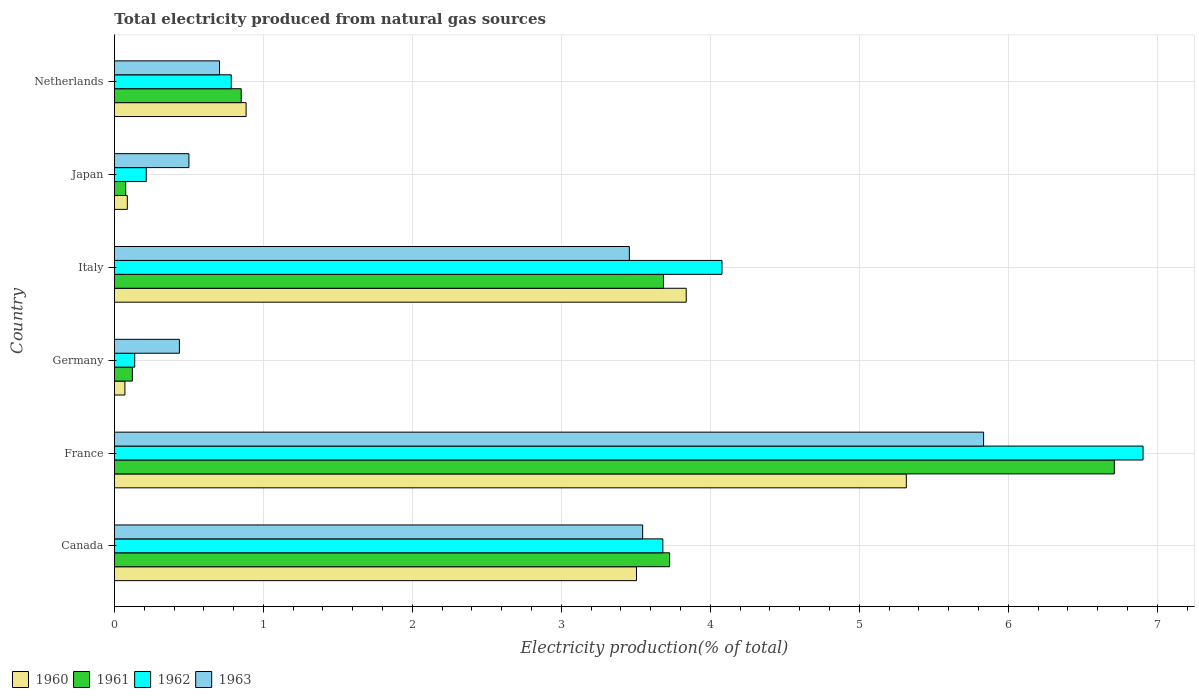How many different coloured bars are there?
Give a very brief answer. 4. Are the number of bars on each tick of the Y-axis equal?
Provide a succinct answer. Yes. What is the label of the 6th group of bars from the top?
Keep it short and to the point. Canada. In how many cases, is the number of bars for a given country not equal to the number of legend labels?
Offer a terse response. 0. What is the total electricity produced in 1963 in Germany?
Provide a succinct answer. 0.44. Across all countries, what is the maximum total electricity produced in 1960?
Ensure brevity in your answer.  5.32. Across all countries, what is the minimum total electricity produced in 1962?
Provide a short and direct response. 0.14. In which country was the total electricity produced in 1963 maximum?
Keep it short and to the point. France. What is the total total electricity produced in 1961 in the graph?
Offer a very short reply. 15.17. What is the difference between the total electricity produced in 1960 in Japan and that in Netherlands?
Offer a very short reply. -0.8. What is the difference between the total electricity produced in 1960 in France and the total electricity produced in 1961 in Netherlands?
Give a very brief answer. 4.46. What is the average total electricity produced in 1963 per country?
Offer a very short reply. 2.41. What is the difference between the total electricity produced in 1961 and total electricity produced in 1963 in Netherlands?
Your answer should be compact. 0.15. What is the ratio of the total electricity produced in 1960 in Canada to that in Italy?
Provide a short and direct response. 0.91. What is the difference between the highest and the second highest total electricity produced in 1961?
Provide a short and direct response. 2.99. What is the difference between the highest and the lowest total electricity produced in 1960?
Provide a succinct answer. 5.25. Is the sum of the total electricity produced in 1962 in France and Germany greater than the maximum total electricity produced in 1963 across all countries?
Ensure brevity in your answer.  Yes. Is it the case that in every country, the sum of the total electricity produced in 1962 and total electricity produced in 1960 is greater than the sum of total electricity produced in 1963 and total electricity produced in 1961?
Ensure brevity in your answer.  No. What does the 4th bar from the bottom in Canada represents?
Offer a terse response. 1963. Is it the case that in every country, the sum of the total electricity produced in 1962 and total electricity produced in 1961 is greater than the total electricity produced in 1960?
Provide a short and direct response. Yes. How many bars are there?
Keep it short and to the point. 24. Are all the bars in the graph horizontal?
Your answer should be very brief. Yes. How many countries are there in the graph?
Make the answer very short. 6. Does the graph contain any zero values?
Your answer should be very brief. No. Where does the legend appear in the graph?
Provide a succinct answer. Bottom left. What is the title of the graph?
Ensure brevity in your answer.  Total electricity produced from natural gas sources. What is the Electricity production(% of total) in 1960 in Canada?
Provide a short and direct response. 3.5. What is the Electricity production(% of total) of 1961 in Canada?
Your answer should be compact. 3.73. What is the Electricity production(% of total) in 1962 in Canada?
Provide a succinct answer. 3.68. What is the Electricity production(% of total) of 1963 in Canada?
Make the answer very short. 3.55. What is the Electricity production(% of total) of 1960 in France?
Provide a succinct answer. 5.32. What is the Electricity production(% of total) in 1961 in France?
Provide a short and direct response. 6.71. What is the Electricity production(% of total) of 1962 in France?
Your answer should be very brief. 6.91. What is the Electricity production(% of total) of 1963 in France?
Keep it short and to the point. 5.83. What is the Electricity production(% of total) in 1960 in Germany?
Give a very brief answer. 0.07. What is the Electricity production(% of total) of 1961 in Germany?
Your response must be concise. 0.12. What is the Electricity production(% of total) in 1962 in Germany?
Make the answer very short. 0.14. What is the Electricity production(% of total) of 1963 in Germany?
Ensure brevity in your answer.  0.44. What is the Electricity production(% of total) of 1960 in Italy?
Offer a very short reply. 3.84. What is the Electricity production(% of total) of 1961 in Italy?
Your answer should be compact. 3.69. What is the Electricity production(% of total) of 1962 in Italy?
Provide a short and direct response. 4.08. What is the Electricity production(% of total) in 1963 in Italy?
Offer a terse response. 3.46. What is the Electricity production(% of total) in 1960 in Japan?
Your answer should be compact. 0.09. What is the Electricity production(% of total) in 1961 in Japan?
Ensure brevity in your answer.  0.08. What is the Electricity production(% of total) in 1962 in Japan?
Offer a very short reply. 0.21. What is the Electricity production(% of total) in 1963 in Japan?
Offer a terse response. 0.5. What is the Electricity production(% of total) in 1960 in Netherlands?
Your answer should be very brief. 0.88. What is the Electricity production(% of total) of 1961 in Netherlands?
Keep it short and to the point. 0.85. What is the Electricity production(% of total) of 1962 in Netherlands?
Offer a very short reply. 0.78. What is the Electricity production(% of total) in 1963 in Netherlands?
Provide a succinct answer. 0.71. Across all countries, what is the maximum Electricity production(% of total) of 1960?
Your answer should be very brief. 5.32. Across all countries, what is the maximum Electricity production(% of total) of 1961?
Provide a succinct answer. 6.71. Across all countries, what is the maximum Electricity production(% of total) in 1962?
Keep it short and to the point. 6.91. Across all countries, what is the maximum Electricity production(% of total) in 1963?
Your response must be concise. 5.83. Across all countries, what is the minimum Electricity production(% of total) of 1960?
Offer a terse response. 0.07. Across all countries, what is the minimum Electricity production(% of total) in 1961?
Make the answer very short. 0.08. Across all countries, what is the minimum Electricity production(% of total) of 1962?
Provide a short and direct response. 0.14. Across all countries, what is the minimum Electricity production(% of total) of 1963?
Your response must be concise. 0.44. What is the total Electricity production(% of total) in 1960 in the graph?
Provide a succinct answer. 13.7. What is the total Electricity production(% of total) of 1961 in the graph?
Offer a terse response. 15.17. What is the total Electricity production(% of total) of 1962 in the graph?
Ensure brevity in your answer.  15.8. What is the total Electricity production(% of total) in 1963 in the graph?
Give a very brief answer. 14.48. What is the difference between the Electricity production(% of total) in 1960 in Canada and that in France?
Ensure brevity in your answer.  -1.81. What is the difference between the Electricity production(% of total) of 1961 in Canada and that in France?
Offer a very short reply. -2.99. What is the difference between the Electricity production(% of total) in 1962 in Canada and that in France?
Ensure brevity in your answer.  -3.22. What is the difference between the Electricity production(% of total) of 1963 in Canada and that in France?
Offer a terse response. -2.29. What is the difference between the Electricity production(% of total) in 1960 in Canada and that in Germany?
Your response must be concise. 3.43. What is the difference between the Electricity production(% of total) of 1961 in Canada and that in Germany?
Ensure brevity in your answer.  3.61. What is the difference between the Electricity production(% of total) in 1962 in Canada and that in Germany?
Ensure brevity in your answer.  3.55. What is the difference between the Electricity production(% of total) in 1963 in Canada and that in Germany?
Your answer should be very brief. 3.11. What is the difference between the Electricity production(% of total) of 1960 in Canada and that in Italy?
Make the answer very short. -0.33. What is the difference between the Electricity production(% of total) of 1961 in Canada and that in Italy?
Ensure brevity in your answer.  0.04. What is the difference between the Electricity production(% of total) of 1962 in Canada and that in Italy?
Offer a terse response. -0.4. What is the difference between the Electricity production(% of total) of 1963 in Canada and that in Italy?
Provide a short and direct response. 0.09. What is the difference between the Electricity production(% of total) of 1960 in Canada and that in Japan?
Offer a terse response. 3.42. What is the difference between the Electricity production(% of total) of 1961 in Canada and that in Japan?
Your response must be concise. 3.65. What is the difference between the Electricity production(% of total) in 1962 in Canada and that in Japan?
Make the answer very short. 3.47. What is the difference between the Electricity production(% of total) in 1963 in Canada and that in Japan?
Provide a short and direct response. 3.05. What is the difference between the Electricity production(% of total) in 1960 in Canada and that in Netherlands?
Offer a very short reply. 2.62. What is the difference between the Electricity production(% of total) in 1961 in Canada and that in Netherlands?
Make the answer very short. 2.88. What is the difference between the Electricity production(% of total) of 1962 in Canada and that in Netherlands?
Provide a short and direct response. 2.9. What is the difference between the Electricity production(% of total) of 1963 in Canada and that in Netherlands?
Make the answer very short. 2.84. What is the difference between the Electricity production(% of total) of 1960 in France and that in Germany?
Offer a terse response. 5.25. What is the difference between the Electricity production(% of total) in 1961 in France and that in Germany?
Keep it short and to the point. 6.59. What is the difference between the Electricity production(% of total) of 1962 in France and that in Germany?
Provide a succinct answer. 6.77. What is the difference between the Electricity production(% of total) of 1963 in France and that in Germany?
Provide a succinct answer. 5.4. What is the difference between the Electricity production(% of total) in 1960 in France and that in Italy?
Make the answer very short. 1.48. What is the difference between the Electricity production(% of total) of 1961 in France and that in Italy?
Offer a very short reply. 3.03. What is the difference between the Electricity production(% of total) of 1962 in France and that in Italy?
Ensure brevity in your answer.  2.83. What is the difference between the Electricity production(% of total) of 1963 in France and that in Italy?
Give a very brief answer. 2.38. What is the difference between the Electricity production(% of total) of 1960 in France and that in Japan?
Make the answer very short. 5.23. What is the difference between the Electricity production(% of total) in 1961 in France and that in Japan?
Provide a succinct answer. 6.64. What is the difference between the Electricity production(% of total) of 1962 in France and that in Japan?
Ensure brevity in your answer.  6.69. What is the difference between the Electricity production(% of total) of 1963 in France and that in Japan?
Make the answer very short. 5.33. What is the difference between the Electricity production(% of total) in 1960 in France and that in Netherlands?
Provide a succinct answer. 4.43. What is the difference between the Electricity production(% of total) of 1961 in France and that in Netherlands?
Ensure brevity in your answer.  5.86. What is the difference between the Electricity production(% of total) of 1962 in France and that in Netherlands?
Give a very brief answer. 6.12. What is the difference between the Electricity production(% of total) of 1963 in France and that in Netherlands?
Make the answer very short. 5.13. What is the difference between the Electricity production(% of total) of 1960 in Germany and that in Italy?
Provide a succinct answer. -3.77. What is the difference between the Electricity production(% of total) of 1961 in Germany and that in Italy?
Your answer should be compact. -3.57. What is the difference between the Electricity production(% of total) in 1962 in Germany and that in Italy?
Make the answer very short. -3.94. What is the difference between the Electricity production(% of total) of 1963 in Germany and that in Italy?
Ensure brevity in your answer.  -3.02. What is the difference between the Electricity production(% of total) in 1960 in Germany and that in Japan?
Your answer should be very brief. -0.02. What is the difference between the Electricity production(% of total) of 1961 in Germany and that in Japan?
Provide a succinct answer. 0.04. What is the difference between the Electricity production(% of total) of 1962 in Germany and that in Japan?
Offer a terse response. -0.08. What is the difference between the Electricity production(% of total) in 1963 in Germany and that in Japan?
Your answer should be compact. -0.06. What is the difference between the Electricity production(% of total) of 1960 in Germany and that in Netherlands?
Ensure brevity in your answer.  -0.81. What is the difference between the Electricity production(% of total) in 1961 in Germany and that in Netherlands?
Your answer should be compact. -0.73. What is the difference between the Electricity production(% of total) in 1962 in Germany and that in Netherlands?
Make the answer very short. -0.65. What is the difference between the Electricity production(% of total) of 1963 in Germany and that in Netherlands?
Offer a very short reply. -0.27. What is the difference between the Electricity production(% of total) in 1960 in Italy and that in Japan?
Your response must be concise. 3.75. What is the difference between the Electricity production(% of total) of 1961 in Italy and that in Japan?
Offer a very short reply. 3.61. What is the difference between the Electricity production(% of total) of 1962 in Italy and that in Japan?
Make the answer very short. 3.86. What is the difference between the Electricity production(% of total) in 1963 in Italy and that in Japan?
Offer a very short reply. 2.96. What is the difference between the Electricity production(% of total) in 1960 in Italy and that in Netherlands?
Keep it short and to the point. 2.95. What is the difference between the Electricity production(% of total) in 1961 in Italy and that in Netherlands?
Make the answer very short. 2.83. What is the difference between the Electricity production(% of total) of 1962 in Italy and that in Netherlands?
Offer a terse response. 3.29. What is the difference between the Electricity production(% of total) of 1963 in Italy and that in Netherlands?
Your response must be concise. 2.75. What is the difference between the Electricity production(% of total) of 1960 in Japan and that in Netherlands?
Make the answer very short. -0.8. What is the difference between the Electricity production(% of total) in 1961 in Japan and that in Netherlands?
Provide a short and direct response. -0.78. What is the difference between the Electricity production(% of total) of 1962 in Japan and that in Netherlands?
Provide a succinct answer. -0.57. What is the difference between the Electricity production(% of total) in 1963 in Japan and that in Netherlands?
Offer a very short reply. -0.21. What is the difference between the Electricity production(% of total) in 1960 in Canada and the Electricity production(% of total) in 1961 in France?
Your answer should be compact. -3.21. What is the difference between the Electricity production(% of total) of 1960 in Canada and the Electricity production(% of total) of 1962 in France?
Your response must be concise. -3.4. What is the difference between the Electricity production(% of total) of 1960 in Canada and the Electricity production(% of total) of 1963 in France?
Offer a terse response. -2.33. What is the difference between the Electricity production(% of total) of 1961 in Canada and the Electricity production(% of total) of 1962 in France?
Offer a terse response. -3.18. What is the difference between the Electricity production(% of total) of 1961 in Canada and the Electricity production(% of total) of 1963 in France?
Your response must be concise. -2.11. What is the difference between the Electricity production(% of total) of 1962 in Canada and the Electricity production(% of total) of 1963 in France?
Offer a very short reply. -2.15. What is the difference between the Electricity production(% of total) in 1960 in Canada and the Electricity production(% of total) in 1961 in Germany?
Provide a short and direct response. 3.38. What is the difference between the Electricity production(% of total) in 1960 in Canada and the Electricity production(% of total) in 1962 in Germany?
Give a very brief answer. 3.37. What is the difference between the Electricity production(% of total) in 1960 in Canada and the Electricity production(% of total) in 1963 in Germany?
Your answer should be compact. 3.07. What is the difference between the Electricity production(% of total) of 1961 in Canada and the Electricity production(% of total) of 1962 in Germany?
Offer a terse response. 3.59. What is the difference between the Electricity production(% of total) in 1961 in Canada and the Electricity production(% of total) in 1963 in Germany?
Offer a very short reply. 3.29. What is the difference between the Electricity production(% of total) of 1962 in Canada and the Electricity production(% of total) of 1963 in Germany?
Your answer should be compact. 3.25. What is the difference between the Electricity production(% of total) of 1960 in Canada and the Electricity production(% of total) of 1961 in Italy?
Give a very brief answer. -0.18. What is the difference between the Electricity production(% of total) of 1960 in Canada and the Electricity production(% of total) of 1962 in Italy?
Make the answer very short. -0.57. What is the difference between the Electricity production(% of total) of 1960 in Canada and the Electricity production(% of total) of 1963 in Italy?
Your answer should be very brief. 0.05. What is the difference between the Electricity production(% of total) in 1961 in Canada and the Electricity production(% of total) in 1962 in Italy?
Your answer should be very brief. -0.35. What is the difference between the Electricity production(% of total) of 1961 in Canada and the Electricity production(% of total) of 1963 in Italy?
Make the answer very short. 0.27. What is the difference between the Electricity production(% of total) of 1962 in Canada and the Electricity production(% of total) of 1963 in Italy?
Your answer should be very brief. 0.23. What is the difference between the Electricity production(% of total) of 1960 in Canada and the Electricity production(% of total) of 1961 in Japan?
Give a very brief answer. 3.43. What is the difference between the Electricity production(% of total) in 1960 in Canada and the Electricity production(% of total) in 1962 in Japan?
Your response must be concise. 3.29. What is the difference between the Electricity production(% of total) of 1960 in Canada and the Electricity production(% of total) of 1963 in Japan?
Your response must be concise. 3. What is the difference between the Electricity production(% of total) of 1961 in Canada and the Electricity production(% of total) of 1962 in Japan?
Your answer should be very brief. 3.51. What is the difference between the Electricity production(% of total) in 1961 in Canada and the Electricity production(% of total) in 1963 in Japan?
Offer a terse response. 3.23. What is the difference between the Electricity production(% of total) of 1962 in Canada and the Electricity production(% of total) of 1963 in Japan?
Offer a terse response. 3.18. What is the difference between the Electricity production(% of total) of 1960 in Canada and the Electricity production(% of total) of 1961 in Netherlands?
Your answer should be compact. 2.65. What is the difference between the Electricity production(% of total) in 1960 in Canada and the Electricity production(% of total) in 1962 in Netherlands?
Provide a succinct answer. 2.72. What is the difference between the Electricity production(% of total) in 1960 in Canada and the Electricity production(% of total) in 1963 in Netherlands?
Your answer should be very brief. 2.8. What is the difference between the Electricity production(% of total) of 1961 in Canada and the Electricity production(% of total) of 1962 in Netherlands?
Provide a succinct answer. 2.94. What is the difference between the Electricity production(% of total) in 1961 in Canada and the Electricity production(% of total) in 1963 in Netherlands?
Give a very brief answer. 3.02. What is the difference between the Electricity production(% of total) of 1962 in Canada and the Electricity production(% of total) of 1963 in Netherlands?
Your answer should be very brief. 2.98. What is the difference between the Electricity production(% of total) in 1960 in France and the Electricity production(% of total) in 1961 in Germany?
Offer a very short reply. 5.2. What is the difference between the Electricity production(% of total) in 1960 in France and the Electricity production(% of total) in 1962 in Germany?
Ensure brevity in your answer.  5.18. What is the difference between the Electricity production(% of total) of 1960 in France and the Electricity production(% of total) of 1963 in Germany?
Your answer should be very brief. 4.88. What is the difference between the Electricity production(% of total) of 1961 in France and the Electricity production(% of total) of 1962 in Germany?
Provide a short and direct response. 6.58. What is the difference between the Electricity production(% of total) of 1961 in France and the Electricity production(% of total) of 1963 in Germany?
Give a very brief answer. 6.28. What is the difference between the Electricity production(% of total) in 1962 in France and the Electricity production(% of total) in 1963 in Germany?
Ensure brevity in your answer.  6.47. What is the difference between the Electricity production(% of total) of 1960 in France and the Electricity production(% of total) of 1961 in Italy?
Your response must be concise. 1.63. What is the difference between the Electricity production(% of total) of 1960 in France and the Electricity production(% of total) of 1962 in Italy?
Provide a succinct answer. 1.24. What is the difference between the Electricity production(% of total) of 1960 in France and the Electricity production(% of total) of 1963 in Italy?
Give a very brief answer. 1.86. What is the difference between the Electricity production(% of total) of 1961 in France and the Electricity production(% of total) of 1962 in Italy?
Offer a terse response. 2.63. What is the difference between the Electricity production(% of total) of 1961 in France and the Electricity production(% of total) of 1963 in Italy?
Your response must be concise. 3.26. What is the difference between the Electricity production(% of total) in 1962 in France and the Electricity production(% of total) in 1963 in Italy?
Keep it short and to the point. 3.45. What is the difference between the Electricity production(% of total) in 1960 in France and the Electricity production(% of total) in 1961 in Japan?
Your answer should be compact. 5.24. What is the difference between the Electricity production(% of total) in 1960 in France and the Electricity production(% of total) in 1962 in Japan?
Give a very brief answer. 5.1. What is the difference between the Electricity production(% of total) of 1960 in France and the Electricity production(% of total) of 1963 in Japan?
Offer a terse response. 4.82. What is the difference between the Electricity production(% of total) of 1961 in France and the Electricity production(% of total) of 1962 in Japan?
Ensure brevity in your answer.  6.5. What is the difference between the Electricity production(% of total) of 1961 in France and the Electricity production(% of total) of 1963 in Japan?
Your response must be concise. 6.21. What is the difference between the Electricity production(% of total) in 1962 in France and the Electricity production(% of total) in 1963 in Japan?
Offer a terse response. 6.4. What is the difference between the Electricity production(% of total) of 1960 in France and the Electricity production(% of total) of 1961 in Netherlands?
Offer a very short reply. 4.46. What is the difference between the Electricity production(% of total) of 1960 in France and the Electricity production(% of total) of 1962 in Netherlands?
Provide a short and direct response. 4.53. What is the difference between the Electricity production(% of total) in 1960 in France and the Electricity production(% of total) in 1963 in Netherlands?
Offer a very short reply. 4.61. What is the difference between the Electricity production(% of total) in 1961 in France and the Electricity production(% of total) in 1962 in Netherlands?
Make the answer very short. 5.93. What is the difference between the Electricity production(% of total) of 1961 in France and the Electricity production(% of total) of 1963 in Netherlands?
Offer a very short reply. 6.01. What is the difference between the Electricity production(% of total) in 1962 in France and the Electricity production(% of total) in 1963 in Netherlands?
Your answer should be very brief. 6.2. What is the difference between the Electricity production(% of total) of 1960 in Germany and the Electricity production(% of total) of 1961 in Italy?
Offer a very short reply. -3.62. What is the difference between the Electricity production(% of total) of 1960 in Germany and the Electricity production(% of total) of 1962 in Italy?
Give a very brief answer. -4.01. What is the difference between the Electricity production(% of total) of 1960 in Germany and the Electricity production(% of total) of 1963 in Italy?
Your answer should be very brief. -3.39. What is the difference between the Electricity production(% of total) in 1961 in Germany and the Electricity production(% of total) in 1962 in Italy?
Your answer should be compact. -3.96. What is the difference between the Electricity production(% of total) of 1961 in Germany and the Electricity production(% of total) of 1963 in Italy?
Give a very brief answer. -3.34. What is the difference between the Electricity production(% of total) in 1962 in Germany and the Electricity production(% of total) in 1963 in Italy?
Offer a very short reply. -3.32. What is the difference between the Electricity production(% of total) of 1960 in Germany and the Electricity production(% of total) of 1961 in Japan?
Your answer should be compact. -0.01. What is the difference between the Electricity production(% of total) in 1960 in Germany and the Electricity production(% of total) in 1962 in Japan?
Offer a terse response. -0.14. What is the difference between the Electricity production(% of total) in 1960 in Germany and the Electricity production(% of total) in 1963 in Japan?
Give a very brief answer. -0.43. What is the difference between the Electricity production(% of total) of 1961 in Germany and the Electricity production(% of total) of 1962 in Japan?
Ensure brevity in your answer.  -0.09. What is the difference between the Electricity production(% of total) in 1961 in Germany and the Electricity production(% of total) in 1963 in Japan?
Provide a short and direct response. -0.38. What is the difference between the Electricity production(% of total) in 1962 in Germany and the Electricity production(% of total) in 1963 in Japan?
Offer a terse response. -0.36. What is the difference between the Electricity production(% of total) in 1960 in Germany and the Electricity production(% of total) in 1961 in Netherlands?
Your answer should be very brief. -0.78. What is the difference between the Electricity production(% of total) in 1960 in Germany and the Electricity production(% of total) in 1962 in Netherlands?
Ensure brevity in your answer.  -0.71. What is the difference between the Electricity production(% of total) of 1960 in Germany and the Electricity production(% of total) of 1963 in Netherlands?
Provide a short and direct response. -0.64. What is the difference between the Electricity production(% of total) of 1961 in Germany and the Electricity production(% of total) of 1962 in Netherlands?
Offer a very short reply. -0.66. What is the difference between the Electricity production(% of total) in 1961 in Germany and the Electricity production(% of total) in 1963 in Netherlands?
Provide a succinct answer. -0.58. What is the difference between the Electricity production(% of total) of 1962 in Germany and the Electricity production(% of total) of 1963 in Netherlands?
Ensure brevity in your answer.  -0.57. What is the difference between the Electricity production(% of total) in 1960 in Italy and the Electricity production(% of total) in 1961 in Japan?
Your answer should be compact. 3.76. What is the difference between the Electricity production(% of total) of 1960 in Italy and the Electricity production(% of total) of 1962 in Japan?
Keep it short and to the point. 3.62. What is the difference between the Electricity production(% of total) of 1960 in Italy and the Electricity production(% of total) of 1963 in Japan?
Keep it short and to the point. 3.34. What is the difference between the Electricity production(% of total) of 1961 in Italy and the Electricity production(% of total) of 1962 in Japan?
Keep it short and to the point. 3.47. What is the difference between the Electricity production(% of total) of 1961 in Italy and the Electricity production(% of total) of 1963 in Japan?
Make the answer very short. 3.19. What is the difference between the Electricity production(% of total) in 1962 in Italy and the Electricity production(% of total) in 1963 in Japan?
Your answer should be compact. 3.58. What is the difference between the Electricity production(% of total) of 1960 in Italy and the Electricity production(% of total) of 1961 in Netherlands?
Keep it short and to the point. 2.99. What is the difference between the Electricity production(% of total) of 1960 in Italy and the Electricity production(% of total) of 1962 in Netherlands?
Your answer should be compact. 3.05. What is the difference between the Electricity production(% of total) of 1960 in Italy and the Electricity production(% of total) of 1963 in Netherlands?
Your answer should be very brief. 3.13. What is the difference between the Electricity production(% of total) in 1961 in Italy and the Electricity production(% of total) in 1962 in Netherlands?
Ensure brevity in your answer.  2.9. What is the difference between the Electricity production(% of total) in 1961 in Italy and the Electricity production(% of total) in 1963 in Netherlands?
Your answer should be very brief. 2.98. What is the difference between the Electricity production(% of total) in 1962 in Italy and the Electricity production(% of total) in 1963 in Netherlands?
Provide a short and direct response. 3.37. What is the difference between the Electricity production(% of total) in 1960 in Japan and the Electricity production(% of total) in 1961 in Netherlands?
Make the answer very short. -0.76. What is the difference between the Electricity production(% of total) of 1960 in Japan and the Electricity production(% of total) of 1962 in Netherlands?
Offer a very short reply. -0.7. What is the difference between the Electricity production(% of total) of 1960 in Japan and the Electricity production(% of total) of 1963 in Netherlands?
Offer a terse response. -0.62. What is the difference between the Electricity production(% of total) in 1961 in Japan and the Electricity production(% of total) in 1962 in Netherlands?
Make the answer very short. -0.71. What is the difference between the Electricity production(% of total) of 1961 in Japan and the Electricity production(% of total) of 1963 in Netherlands?
Ensure brevity in your answer.  -0.63. What is the difference between the Electricity production(% of total) of 1962 in Japan and the Electricity production(% of total) of 1963 in Netherlands?
Your answer should be very brief. -0.49. What is the average Electricity production(% of total) in 1960 per country?
Your answer should be very brief. 2.28. What is the average Electricity production(% of total) in 1961 per country?
Offer a very short reply. 2.53. What is the average Electricity production(% of total) of 1962 per country?
Offer a very short reply. 2.63. What is the average Electricity production(% of total) in 1963 per country?
Your answer should be compact. 2.41. What is the difference between the Electricity production(% of total) of 1960 and Electricity production(% of total) of 1961 in Canada?
Provide a short and direct response. -0.22. What is the difference between the Electricity production(% of total) of 1960 and Electricity production(% of total) of 1962 in Canada?
Offer a very short reply. -0.18. What is the difference between the Electricity production(% of total) in 1960 and Electricity production(% of total) in 1963 in Canada?
Ensure brevity in your answer.  -0.04. What is the difference between the Electricity production(% of total) in 1961 and Electricity production(% of total) in 1962 in Canada?
Offer a terse response. 0.05. What is the difference between the Electricity production(% of total) in 1961 and Electricity production(% of total) in 1963 in Canada?
Offer a very short reply. 0.18. What is the difference between the Electricity production(% of total) of 1962 and Electricity production(% of total) of 1963 in Canada?
Offer a terse response. 0.14. What is the difference between the Electricity production(% of total) in 1960 and Electricity production(% of total) in 1961 in France?
Your response must be concise. -1.4. What is the difference between the Electricity production(% of total) in 1960 and Electricity production(% of total) in 1962 in France?
Provide a succinct answer. -1.59. What is the difference between the Electricity production(% of total) of 1960 and Electricity production(% of total) of 1963 in France?
Offer a very short reply. -0.52. What is the difference between the Electricity production(% of total) of 1961 and Electricity production(% of total) of 1962 in France?
Your answer should be compact. -0.19. What is the difference between the Electricity production(% of total) in 1961 and Electricity production(% of total) in 1963 in France?
Offer a very short reply. 0.88. What is the difference between the Electricity production(% of total) of 1962 and Electricity production(% of total) of 1963 in France?
Make the answer very short. 1.07. What is the difference between the Electricity production(% of total) of 1960 and Electricity production(% of total) of 1962 in Germany?
Give a very brief answer. -0.07. What is the difference between the Electricity production(% of total) in 1960 and Electricity production(% of total) in 1963 in Germany?
Make the answer very short. -0.37. What is the difference between the Electricity production(% of total) in 1961 and Electricity production(% of total) in 1962 in Germany?
Provide a succinct answer. -0.02. What is the difference between the Electricity production(% of total) in 1961 and Electricity production(% of total) in 1963 in Germany?
Keep it short and to the point. -0.32. What is the difference between the Electricity production(% of total) of 1962 and Electricity production(% of total) of 1963 in Germany?
Provide a short and direct response. -0.3. What is the difference between the Electricity production(% of total) of 1960 and Electricity production(% of total) of 1961 in Italy?
Offer a very short reply. 0.15. What is the difference between the Electricity production(% of total) of 1960 and Electricity production(% of total) of 1962 in Italy?
Provide a succinct answer. -0.24. What is the difference between the Electricity production(% of total) in 1960 and Electricity production(% of total) in 1963 in Italy?
Offer a terse response. 0.38. What is the difference between the Electricity production(% of total) in 1961 and Electricity production(% of total) in 1962 in Italy?
Keep it short and to the point. -0.39. What is the difference between the Electricity production(% of total) of 1961 and Electricity production(% of total) of 1963 in Italy?
Offer a terse response. 0.23. What is the difference between the Electricity production(% of total) of 1962 and Electricity production(% of total) of 1963 in Italy?
Your answer should be compact. 0.62. What is the difference between the Electricity production(% of total) of 1960 and Electricity production(% of total) of 1961 in Japan?
Your answer should be compact. 0.01. What is the difference between the Electricity production(% of total) in 1960 and Electricity production(% of total) in 1962 in Japan?
Your answer should be compact. -0.13. What is the difference between the Electricity production(% of total) in 1960 and Electricity production(% of total) in 1963 in Japan?
Provide a short and direct response. -0.41. What is the difference between the Electricity production(% of total) of 1961 and Electricity production(% of total) of 1962 in Japan?
Provide a short and direct response. -0.14. What is the difference between the Electricity production(% of total) in 1961 and Electricity production(% of total) in 1963 in Japan?
Give a very brief answer. -0.42. What is the difference between the Electricity production(% of total) of 1962 and Electricity production(% of total) of 1963 in Japan?
Offer a terse response. -0.29. What is the difference between the Electricity production(% of total) in 1960 and Electricity production(% of total) in 1961 in Netherlands?
Ensure brevity in your answer.  0.03. What is the difference between the Electricity production(% of total) in 1960 and Electricity production(% of total) in 1962 in Netherlands?
Give a very brief answer. 0.1. What is the difference between the Electricity production(% of total) of 1960 and Electricity production(% of total) of 1963 in Netherlands?
Your answer should be compact. 0.18. What is the difference between the Electricity production(% of total) of 1961 and Electricity production(% of total) of 1962 in Netherlands?
Provide a short and direct response. 0.07. What is the difference between the Electricity production(% of total) in 1961 and Electricity production(% of total) in 1963 in Netherlands?
Give a very brief answer. 0.15. What is the difference between the Electricity production(% of total) of 1962 and Electricity production(% of total) of 1963 in Netherlands?
Offer a terse response. 0.08. What is the ratio of the Electricity production(% of total) of 1960 in Canada to that in France?
Give a very brief answer. 0.66. What is the ratio of the Electricity production(% of total) of 1961 in Canada to that in France?
Offer a terse response. 0.56. What is the ratio of the Electricity production(% of total) in 1962 in Canada to that in France?
Give a very brief answer. 0.53. What is the ratio of the Electricity production(% of total) of 1963 in Canada to that in France?
Ensure brevity in your answer.  0.61. What is the ratio of the Electricity production(% of total) of 1960 in Canada to that in Germany?
Offer a terse response. 49.85. What is the ratio of the Electricity production(% of total) in 1961 in Canada to that in Germany?
Provide a succinct answer. 30.98. What is the ratio of the Electricity production(% of total) in 1962 in Canada to that in Germany?
Your answer should be compact. 27.02. What is the ratio of the Electricity production(% of total) in 1963 in Canada to that in Germany?
Keep it short and to the point. 8.13. What is the ratio of the Electricity production(% of total) of 1960 in Canada to that in Italy?
Provide a succinct answer. 0.91. What is the ratio of the Electricity production(% of total) of 1961 in Canada to that in Italy?
Offer a terse response. 1.01. What is the ratio of the Electricity production(% of total) in 1962 in Canada to that in Italy?
Your answer should be compact. 0.9. What is the ratio of the Electricity production(% of total) of 1963 in Canada to that in Italy?
Offer a terse response. 1.03. What is the ratio of the Electricity production(% of total) in 1960 in Canada to that in Japan?
Keep it short and to the point. 40.48. What is the ratio of the Electricity production(% of total) of 1961 in Canada to that in Japan?
Keep it short and to the point. 49.23. What is the ratio of the Electricity production(% of total) in 1962 in Canada to that in Japan?
Your answer should be compact. 17.23. What is the ratio of the Electricity production(% of total) of 1963 in Canada to that in Japan?
Your answer should be very brief. 7.09. What is the ratio of the Electricity production(% of total) in 1960 in Canada to that in Netherlands?
Keep it short and to the point. 3.96. What is the ratio of the Electricity production(% of total) of 1961 in Canada to that in Netherlands?
Provide a succinct answer. 4.38. What is the ratio of the Electricity production(% of total) in 1962 in Canada to that in Netherlands?
Provide a short and direct response. 4.69. What is the ratio of the Electricity production(% of total) in 1963 in Canada to that in Netherlands?
Your answer should be compact. 5.03. What is the ratio of the Electricity production(% of total) in 1960 in France to that in Germany?
Ensure brevity in your answer.  75.62. What is the ratio of the Electricity production(% of total) in 1961 in France to that in Germany?
Keep it short and to the point. 55.79. What is the ratio of the Electricity production(% of total) in 1962 in France to that in Germany?
Ensure brevity in your answer.  50.69. What is the ratio of the Electricity production(% of total) of 1963 in France to that in Germany?
Your response must be concise. 13.38. What is the ratio of the Electricity production(% of total) in 1960 in France to that in Italy?
Your response must be concise. 1.39. What is the ratio of the Electricity production(% of total) in 1961 in France to that in Italy?
Give a very brief answer. 1.82. What is the ratio of the Electricity production(% of total) in 1962 in France to that in Italy?
Your response must be concise. 1.69. What is the ratio of the Electricity production(% of total) of 1963 in France to that in Italy?
Offer a very short reply. 1.69. What is the ratio of the Electricity production(% of total) of 1960 in France to that in Japan?
Ensure brevity in your answer.  61.4. What is the ratio of the Electricity production(% of total) of 1961 in France to that in Japan?
Offer a very short reply. 88.67. What is the ratio of the Electricity production(% of total) in 1962 in France to that in Japan?
Provide a succinct answer. 32.32. What is the ratio of the Electricity production(% of total) of 1963 in France to that in Japan?
Offer a terse response. 11.67. What is the ratio of the Electricity production(% of total) of 1960 in France to that in Netherlands?
Your answer should be compact. 6.01. What is the ratio of the Electricity production(% of total) of 1961 in France to that in Netherlands?
Provide a succinct answer. 7.89. What is the ratio of the Electricity production(% of total) of 1962 in France to that in Netherlands?
Ensure brevity in your answer.  8.8. What is the ratio of the Electricity production(% of total) of 1963 in France to that in Netherlands?
Make the answer very short. 8.27. What is the ratio of the Electricity production(% of total) in 1960 in Germany to that in Italy?
Provide a succinct answer. 0.02. What is the ratio of the Electricity production(% of total) in 1961 in Germany to that in Italy?
Ensure brevity in your answer.  0.03. What is the ratio of the Electricity production(% of total) of 1962 in Germany to that in Italy?
Offer a terse response. 0.03. What is the ratio of the Electricity production(% of total) of 1963 in Germany to that in Italy?
Keep it short and to the point. 0.13. What is the ratio of the Electricity production(% of total) of 1960 in Germany to that in Japan?
Your response must be concise. 0.81. What is the ratio of the Electricity production(% of total) in 1961 in Germany to that in Japan?
Your answer should be compact. 1.59. What is the ratio of the Electricity production(% of total) of 1962 in Germany to that in Japan?
Your answer should be compact. 0.64. What is the ratio of the Electricity production(% of total) of 1963 in Germany to that in Japan?
Provide a succinct answer. 0.87. What is the ratio of the Electricity production(% of total) of 1960 in Germany to that in Netherlands?
Offer a very short reply. 0.08. What is the ratio of the Electricity production(% of total) in 1961 in Germany to that in Netherlands?
Your response must be concise. 0.14. What is the ratio of the Electricity production(% of total) of 1962 in Germany to that in Netherlands?
Provide a short and direct response. 0.17. What is the ratio of the Electricity production(% of total) in 1963 in Germany to that in Netherlands?
Offer a very short reply. 0.62. What is the ratio of the Electricity production(% of total) in 1960 in Italy to that in Japan?
Offer a terse response. 44.33. What is the ratio of the Electricity production(% of total) in 1961 in Italy to that in Japan?
Ensure brevity in your answer.  48.69. What is the ratio of the Electricity production(% of total) in 1962 in Italy to that in Japan?
Offer a terse response. 19.09. What is the ratio of the Electricity production(% of total) in 1963 in Italy to that in Japan?
Your answer should be very brief. 6.91. What is the ratio of the Electricity production(% of total) of 1960 in Italy to that in Netherlands?
Ensure brevity in your answer.  4.34. What is the ratio of the Electricity production(% of total) of 1961 in Italy to that in Netherlands?
Provide a succinct answer. 4.33. What is the ratio of the Electricity production(% of total) in 1962 in Italy to that in Netherlands?
Provide a short and direct response. 5.2. What is the ratio of the Electricity production(% of total) of 1963 in Italy to that in Netherlands?
Make the answer very short. 4.9. What is the ratio of the Electricity production(% of total) in 1960 in Japan to that in Netherlands?
Offer a terse response. 0.1. What is the ratio of the Electricity production(% of total) in 1961 in Japan to that in Netherlands?
Your answer should be very brief. 0.09. What is the ratio of the Electricity production(% of total) in 1962 in Japan to that in Netherlands?
Give a very brief answer. 0.27. What is the ratio of the Electricity production(% of total) of 1963 in Japan to that in Netherlands?
Offer a very short reply. 0.71. What is the difference between the highest and the second highest Electricity production(% of total) of 1960?
Provide a succinct answer. 1.48. What is the difference between the highest and the second highest Electricity production(% of total) in 1961?
Offer a terse response. 2.99. What is the difference between the highest and the second highest Electricity production(% of total) in 1962?
Your response must be concise. 2.83. What is the difference between the highest and the second highest Electricity production(% of total) of 1963?
Your answer should be very brief. 2.29. What is the difference between the highest and the lowest Electricity production(% of total) of 1960?
Offer a very short reply. 5.25. What is the difference between the highest and the lowest Electricity production(% of total) in 1961?
Provide a short and direct response. 6.64. What is the difference between the highest and the lowest Electricity production(% of total) of 1962?
Keep it short and to the point. 6.77. What is the difference between the highest and the lowest Electricity production(% of total) in 1963?
Provide a succinct answer. 5.4. 